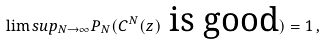Convert formula to latex. <formula><loc_0><loc_0><loc_500><loc_500>\lim s u p _ { N \to \infty } P _ { N } ( C ^ { N } ( z ) \text { is good} ) = 1 \, ,</formula> 